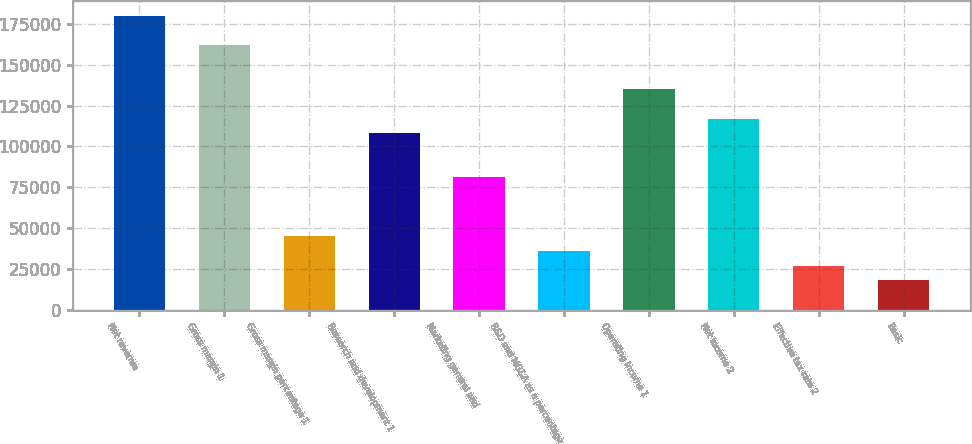<chart> <loc_0><loc_0><loc_500><loc_500><bar_chart><fcel>Net revenue<fcel>Gross margin 1<fcel>Gross margin percentage 1<fcel>Research and development 1<fcel>Marketing general and<fcel>R&D and MG&A as a percentage<fcel>Operating income 1<fcel>Net income 2<fcel>Effective tax rate 2<fcel>Basic<nl><fcel>180023<fcel>162021<fcel>45006.4<fcel>108014<fcel>81010.9<fcel>36005.3<fcel>135018<fcel>117015<fcel>27004.2<fcel>18003.1<nl></chart> 